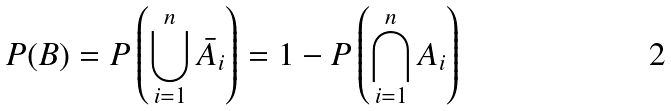<formula> <loc_0><loc_0><loc_500><loc_500>P ( B ) = P \left ( \bigcup _ { i = 1 } ^ { n } \bar { A } _ { i } \right ) = 1 - P \left ( \bigcap _ { i = 1 } ^ { n } A _ { i } \right )</formula> 